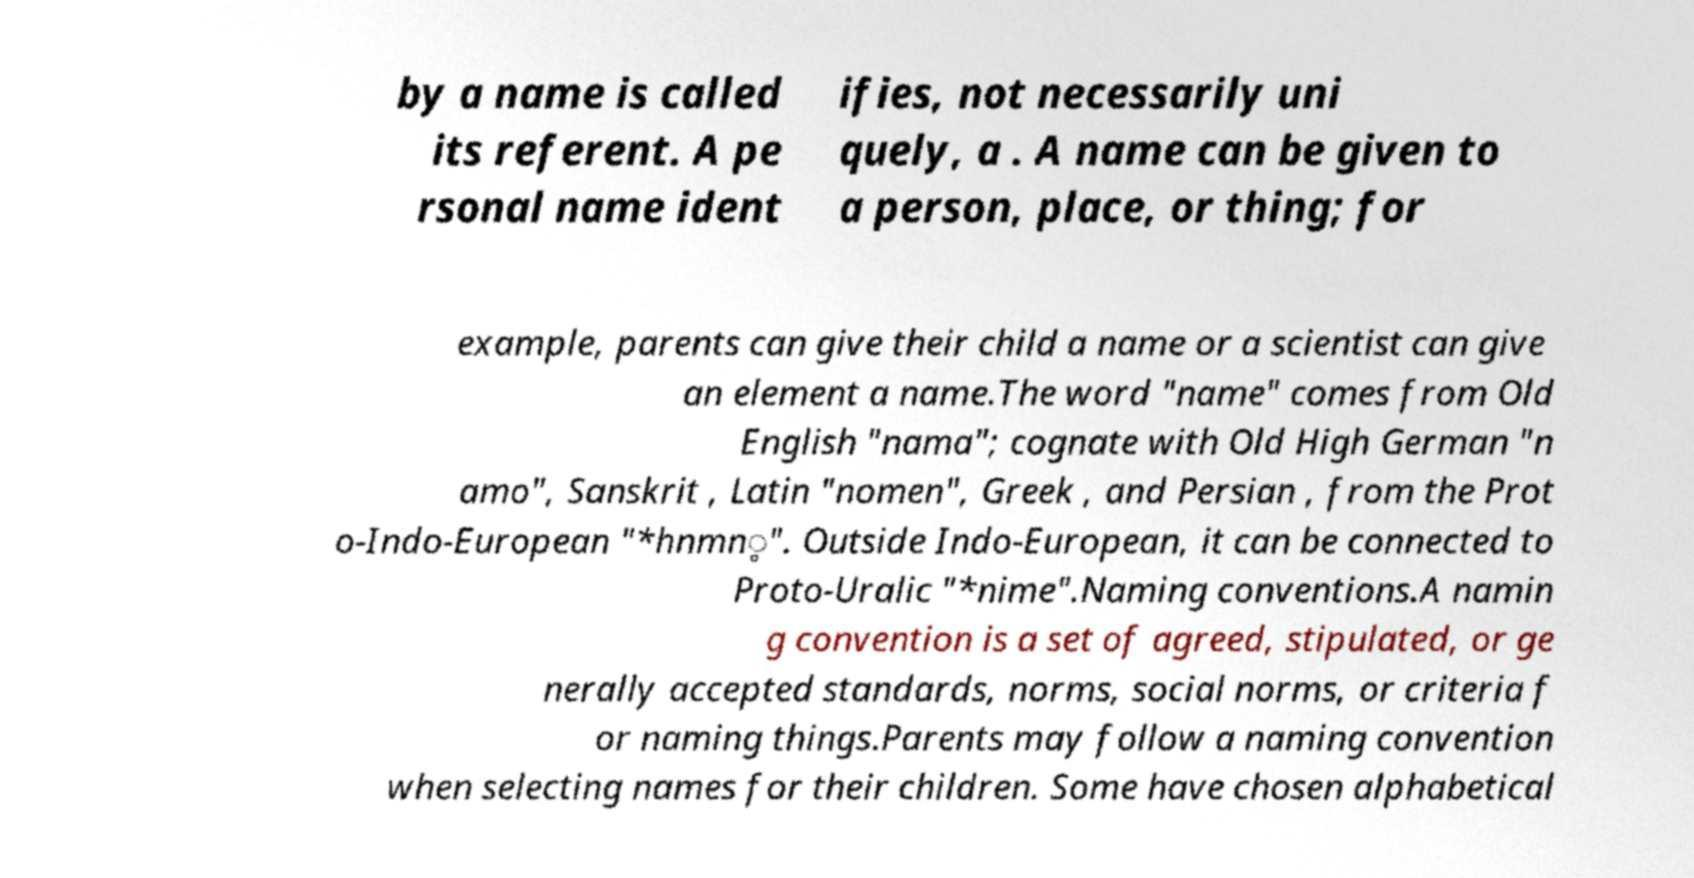Please read and relay the text visible in this image. What does it say? by a name is called its referent. A pe rsonal name ident ifies, not necessarily uni quely, a . A name can be given to a person, place, or thing; for example, parents can give their child a name or a scientist can give an element a name.The word "name" comes from Old English "nama"; cognate with Old High German "n amo", Sanskrit , Latin "nomen", Greek , and Persian , from the Prot o-Indo-European "*hnmn̥". Outside Indo-European, it can be connected to Proto-Uralic "*nime".Naming conventions.A namin g convention is a set of agreed, stipulated, or ge nerally accepted standards, norms, social norms, or criteria f or naming things.Parents may follow a naming convention when selecting names for their children. Some have chosen alphabetical 